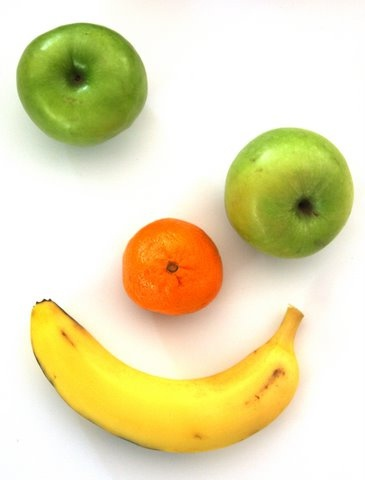Describe the objects in this image and their specific colors. I can see apple in white, olive, and khaki tones, banana in white, gold, yellow, and orange tones, and orange in white, red, orange, and brown tones in this image. 